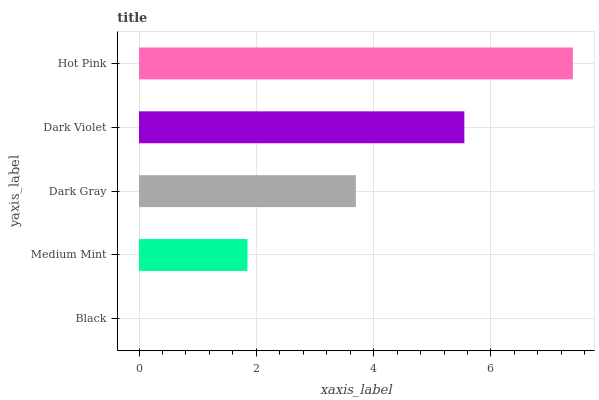Is Black the minimum?
Answer yes or no. Yes. Is Hot Pink the maximum?
Answer yes or no. Yes. Is Medium Mint the minimum?
Answer yes or no. No. Is Medium Mint the maximum?
Answer yes or no. No. Is Medium Mint greater than Black?
Answer yes or no. Yes. Is Black less than Medium Mint?
Answer yes or no. Yes. Is Black greater than Medium Mint?
Answer yes or no. No. Is Medium Mint less than Black?
Answer yes or no. No. Is Dark Gray the high median?
Answer yes or no. Yes. Is Dark Gray the low median?
Answer yes or no. Yes. Is Black the high median?
Answer yes or no. No. Is Dark Violet the low median?
Answer yes or no. No. 